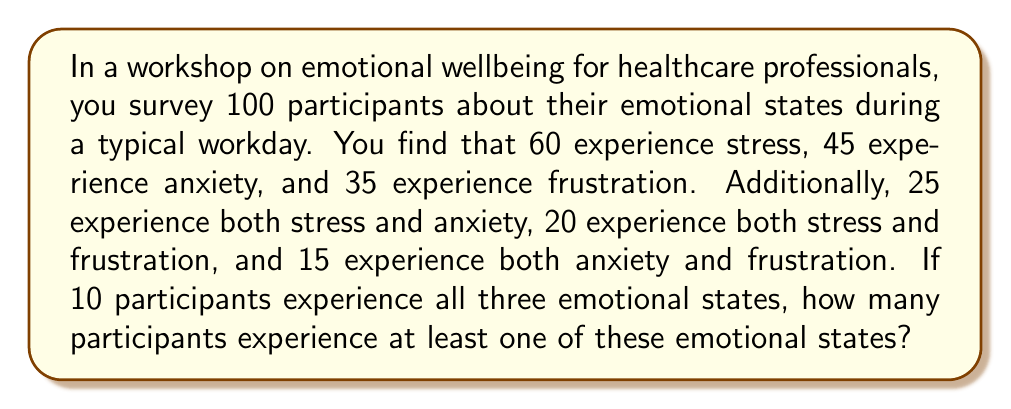Can you answer this question? Let's approach this step-by-step using a Venn diagram and the principle of inclusion-exclusion.

1) First, let's define our sets:
   S: participants experiencing stress
   A: participants experiencing anxiety
   F: participants experiencing frustration

2) We're given:
   $|S| = 60$, $|A| = 45$, $|F| = 35$
   $|S \cap A| = 25$, $|S \cap F| = 20$, $|A \cap F| = 15$
   $|S \cap A \cap F| = 10$

3) The principle of inclusion-exclusion for three sets states:
   $$|S \cup A \cup F| = |S| + |A| + |F| - |S \cap A| - |S \cap F| - |A \cap F| + |S \cap A \cap F|$$

4) Substituting our values:
   $$|S \cup A \cup F| = 60 + 45 + 35 - 25 - 20 - 15 + 10$$

5) Calculating:
   $$|S \cup A \cup F| = 140 - 60 + 10 = 90$$

Therefore, 90 participants experience at least one of these emotional states.

This can be visualized with a Venn diagram:

[asy]
unitsize(1cm);

pair A = (0,0), B = (1.5,0), C = (0.75,1.3);
real r = 1.2;

path c1 = circle(A,r);
path c2 = circle(B,r);
path c3 = circle(C,r);

fill(c1,rgb(1,0.7,0.7));
fill(c2,rgb(0.7,1,0.7));
fill(c3,rgb(0.7,0.7,1));

draw(c1);
draw(c2);
draw(c3);

label("S",A,SW);
label("A",B,SE);
label("F",C,N);

label("25",(-0.3,0.3));
label("20",(0.3,-0.6));
label("15",(1.2,0.3));
label("10",(0.75,0.2));

[/asy]

The regions in the Venn diagram represent the overlapping emotional states, with the central region representing those experiencing all three states.
Answer: 90 participants 